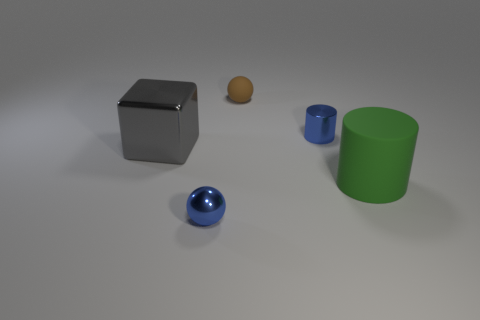How many objects are things left of the metal ball or balls?
Offer a terse response. 3. Are there any blue objects of the same shape as the green object?
Provide a short and direct response. Yes. Are there an equal number of small metallic objects in front of the tiny cylinder and small blue cylinders?
Your answer should be compact. Yes. There is a metallic thing that is the same color as the shiny cylinder; what shape is it?
Offer a terse response. Sphere. What number of cylinders have the same size as the blue shiny sphere?
Keep it short and to the point. 1. There is a small blue shiny cylinder; what number of brown things are to the right of it?
Your answer should be very brief. 0. There is a blue object that is in front of the big object that is behind the large cylinder; what is its material?
Give a very brief answer. Metal. Are there any rubber spheres that have the same color as the rubber cylinder?
Your response must be concise. No. There is a brown object that is the same material as the green cylinder; what is its size?
Ensure brevity in your answer.  Small. Is there anything else that has the same color as the rubber ball?
Provide a succinct answer. No. 